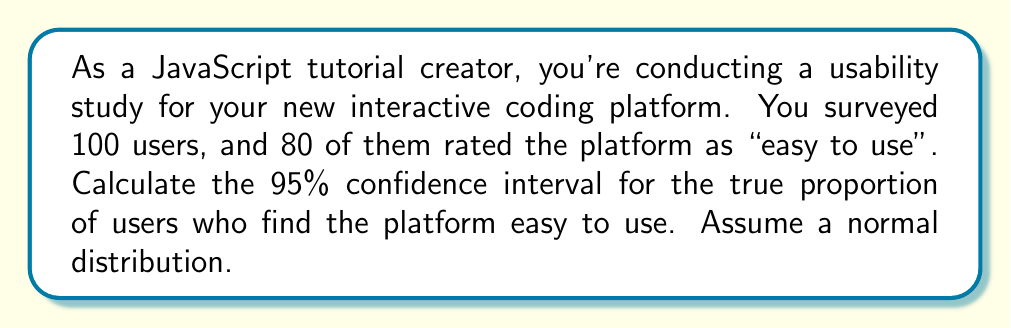Give your solution to this math problem. Let's approach this step-by-step:

1) First, we need to identify our variables:
   $n$ = sample size = 100
   $\hat{p}$ = sample proportion = 80/100 = 0.8
   $z$ = z-score for 95% confidence level = 1.96

2) The formula for the confidence interval is:

   $$\hat{p} \pm z \sqrt{\frac{\hat{p}(1-\hat{p})}{n}}$$

3) Let's calculate the margin of error:

   $$\text{Margin of Error} = z \sqrt{\frac{\hat{p}(1-\hat{p})}{n}}$$
   
   $$= 1.96 \sqrt{\frac{0.8(1-0.8)}{100}}$$
   
   $$= 1.96 \sqrt{\frac{0.16}{100}}$$
   
   $$= 1.96 \sqrt{0.0016}$$
   
   $$= 1.96 * 0.04$$
   
   $$= 0.0784$$

4) Now, we can calculate the confidence interval:

   Lower bound: $0.8 - 0.0784 = 0.7216$
   Upper bound: $0.8 + 0.0784 = 0.8784$

5) Therefore, we are 95% confident that the true proportion of users who find the platform easy to use is between 0.7216 and 0.8784, or between 72.16% and 87.84%.
Answer: (0.7216, 0.8784) 